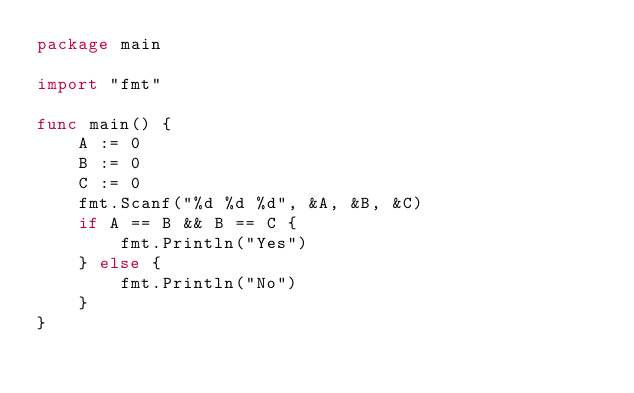<code> <loc_0><loc_0><loc_500><loc_500><_Go_>package main

import "fmt"

func main() {
	A := 0
	B := 0
	C := 0
	fmt.Scanf("%d %d %d", &A, &B, &C)
	if A == B && B == C {
		fmt.Println("Yes")
	} else {
		fmt.Println("No")
	}
}
</code> 